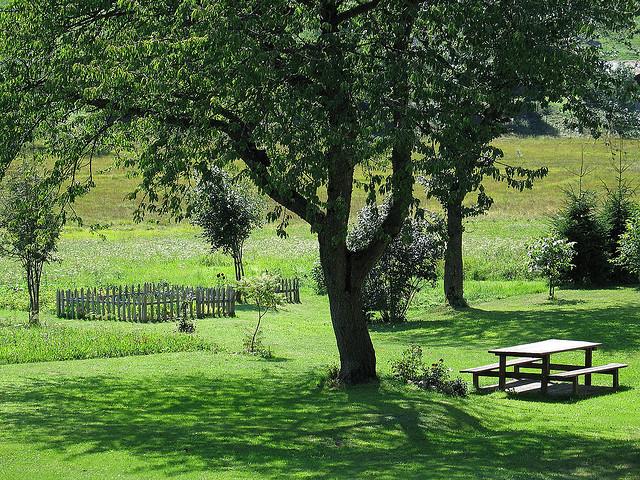What is the fence made of?
Be succinct. Wood. How many trees are there?
Write a very short answer. 8. How many fences are there?
Answer briefly. 2. Is the tree leaning?
Give a very brief answer. No. How many people are sitting at the picnic table?
Concise answer only. 0. What crop is in the background?
Keep it brief. Tomatoes. What is covering the arch?
Short answer required. No arch. Is the picnic table in the shade?
Keep it brief. No. What type of trees are there?
Concise answer only. Oak. What naturally hard surface could someone sit on?
Answer briefly. Ground. 